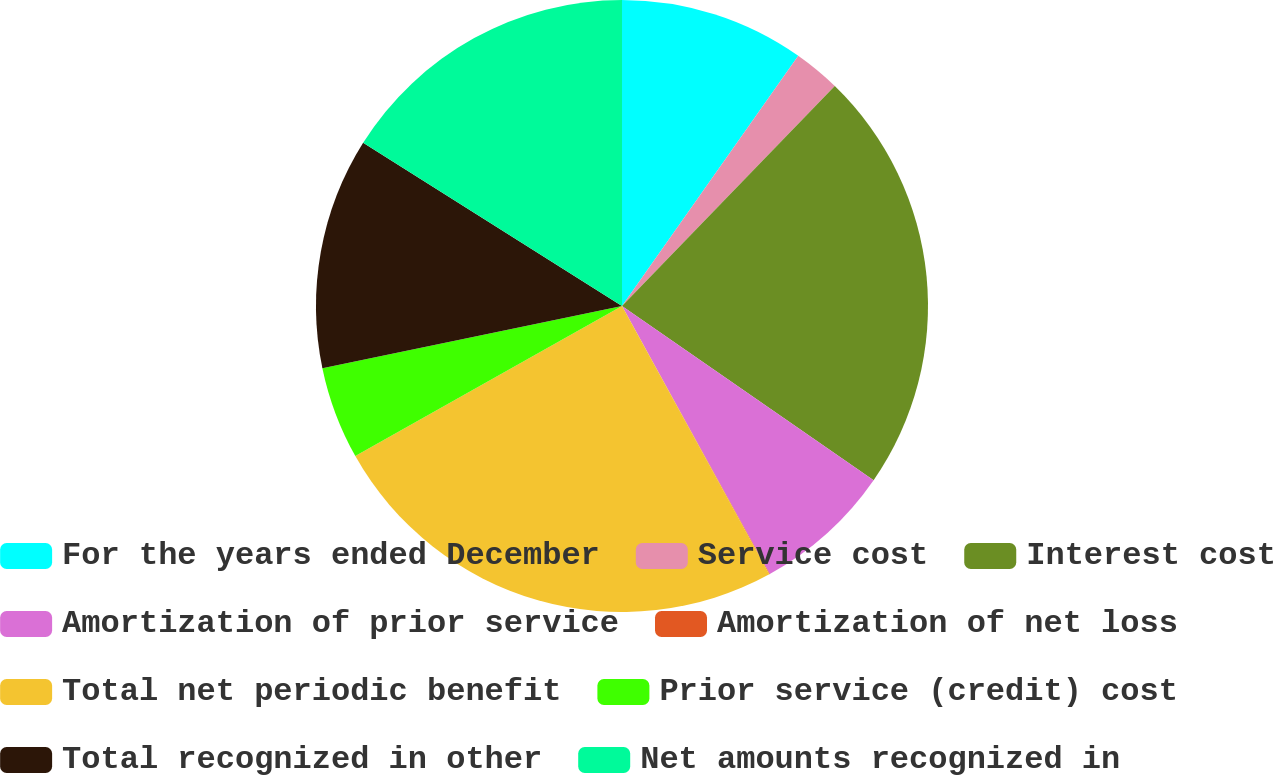<chart> <loc_0><loc_0><loc_500><loc_500><pie_chart><fcel>For the years ended December<fcel>Service cost<fcel>Interest cost<fcel>Amortization of prior service<fcel>Amortization of net loss<fcel>Total net periodic benefit<fcel>Prior service (credit) cost<fcel>Total recognized in other<fcel>Net amounts recognized in<nl><fcel>9.77%<fcel>2.47%<fcel>22.4%<fcel>7.34%<fcel>0.03%<fcel>24.84%<fcel>4.9%<fcel>12.21%<fcel>16.05%<nl></chart> 